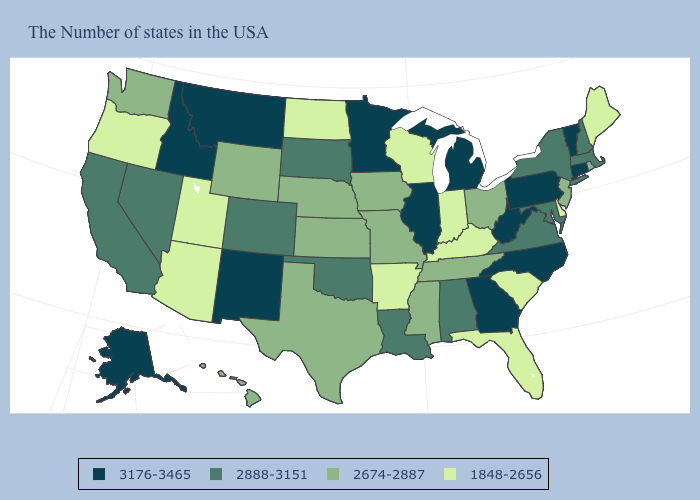Does the map have missing data?
Concise answer only. No. Among the states that border Arizona , does New Mexico have the highest value?
Quick response, please. Yes. What is the value of New Mexico?
Quick response, please. 3176-3465. Among the states that border Michigan , which have the highest value?
Write a very short answer. Ohio. What is the lowest value in states that border Montana?
Write a very short answer. 1848-2656. Name the states that have a value in the range 1848-2656?
Keep it brief. Maine, Delaware, South Carolina, Florida, Kentucky, Indiana, Wisconsin, Arkansas, North Dakota, Utah, Arizona, Oregon. What is the value of Michigan?
Answer briefly. 3176-3465. What is the highest value in states that border Nevada?
Give a very brief answer. 3176-3465. Is the legend a continuous bar?
Be succinct. No. Does Oregon have the highest value in the USA?
Give a very brief answer. No. Does Wisconsin have the lowest value in the USA?
Be succinct. Yes. Name the states that have a value in the range 2888-3151?
Answer briefly. Massachusetts, New Hampshire, New York, Maryland, Virginia, Alabama, Louisiana, Oklahoma, South Dakota, Colorado, Nevada, California. Is the legend a continuous bar?
Keep it brief. No. Among the states that border Oregon , which have the highest value?
Be succinct. Idaho. 